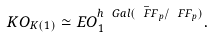Convert formula to latex. <formula><loc_0><loc_0><loc_500><loc_500>K O _ { K ( 1 ) } \simeq E O _ { 1 } ^ { h \ G a l ( \bar { \ F F } _ { p } / \ F F _ { p } ) } .</formula> 